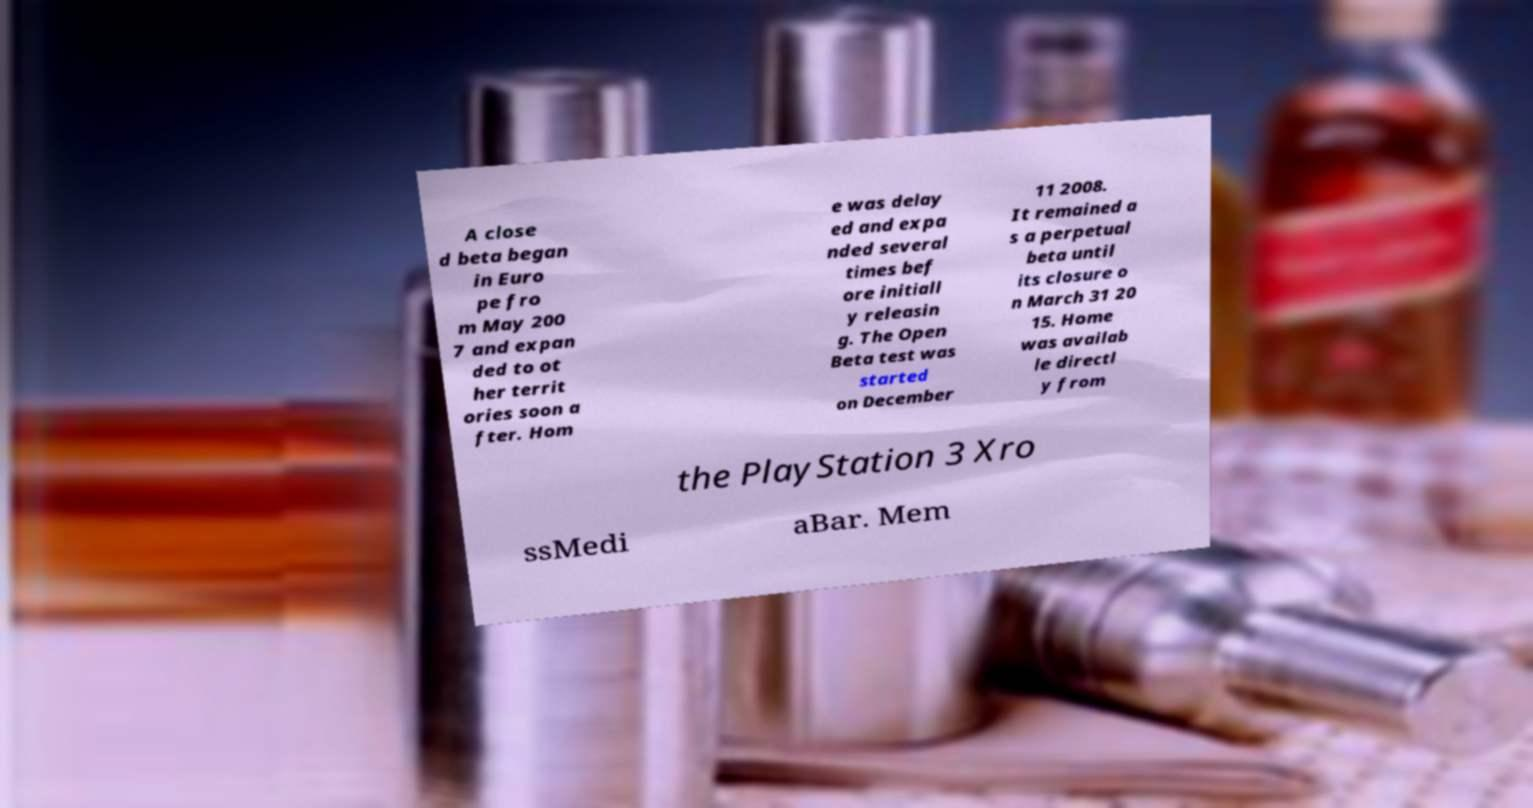I need the written content from this picture converted into text. Can you do that? A close d beta began in Euro pe fro m May 200 7 and expan ded to ot her territ ories soon a fter. Hom e was delay ed and expa nded several times bef ore initiall y releasin g. The Open Beta test was started on December 11 2008. It remained a s a perpetual beta until its closure o n March 31 20 15. Home was availab le directl y from the PlayStation 3 Xro ssMedi aBar. Mem 